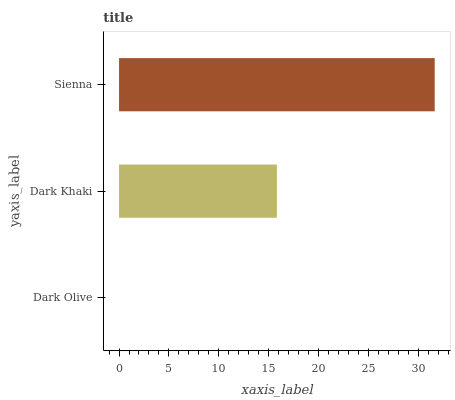Is Dark Olive the minimum?
Answer yes or no. Yes. Is Sienna the maximum?
Answer yes or no. Yes. Is Dark Khaki the minimum?
Answer yes or no. No. Is Dark Khaki the maximum?
Answer yes or no. No. Is Dark Khaki greater than Dark Olive?
Answer yes or no. Yes. Is Dark Olive less than Dark Khaki?
Answer yes or no. Yes. Is Dark Olive greater than Dark Khaki?
Answer yes or no. No. Is Dark Khaki less than Dark Olive?
Answer yes or no. No. Is Dark Khaki the high median?
Answer yes or no. Yes. Is Dark Khaki the low median?
Answer yes or no. Yes. Is Sienna the high median?
Answer yes or no. No. Is Sienna the low median?
Answer yes or no. No. 